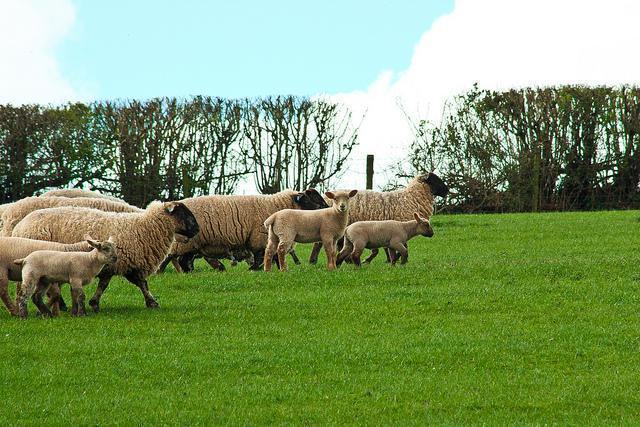Why are some of the animals smaller than other?
Answer the question by selecting the correct answer among the 4 following choices.
Options: Breed, age, injuries, malnourished. Age. 